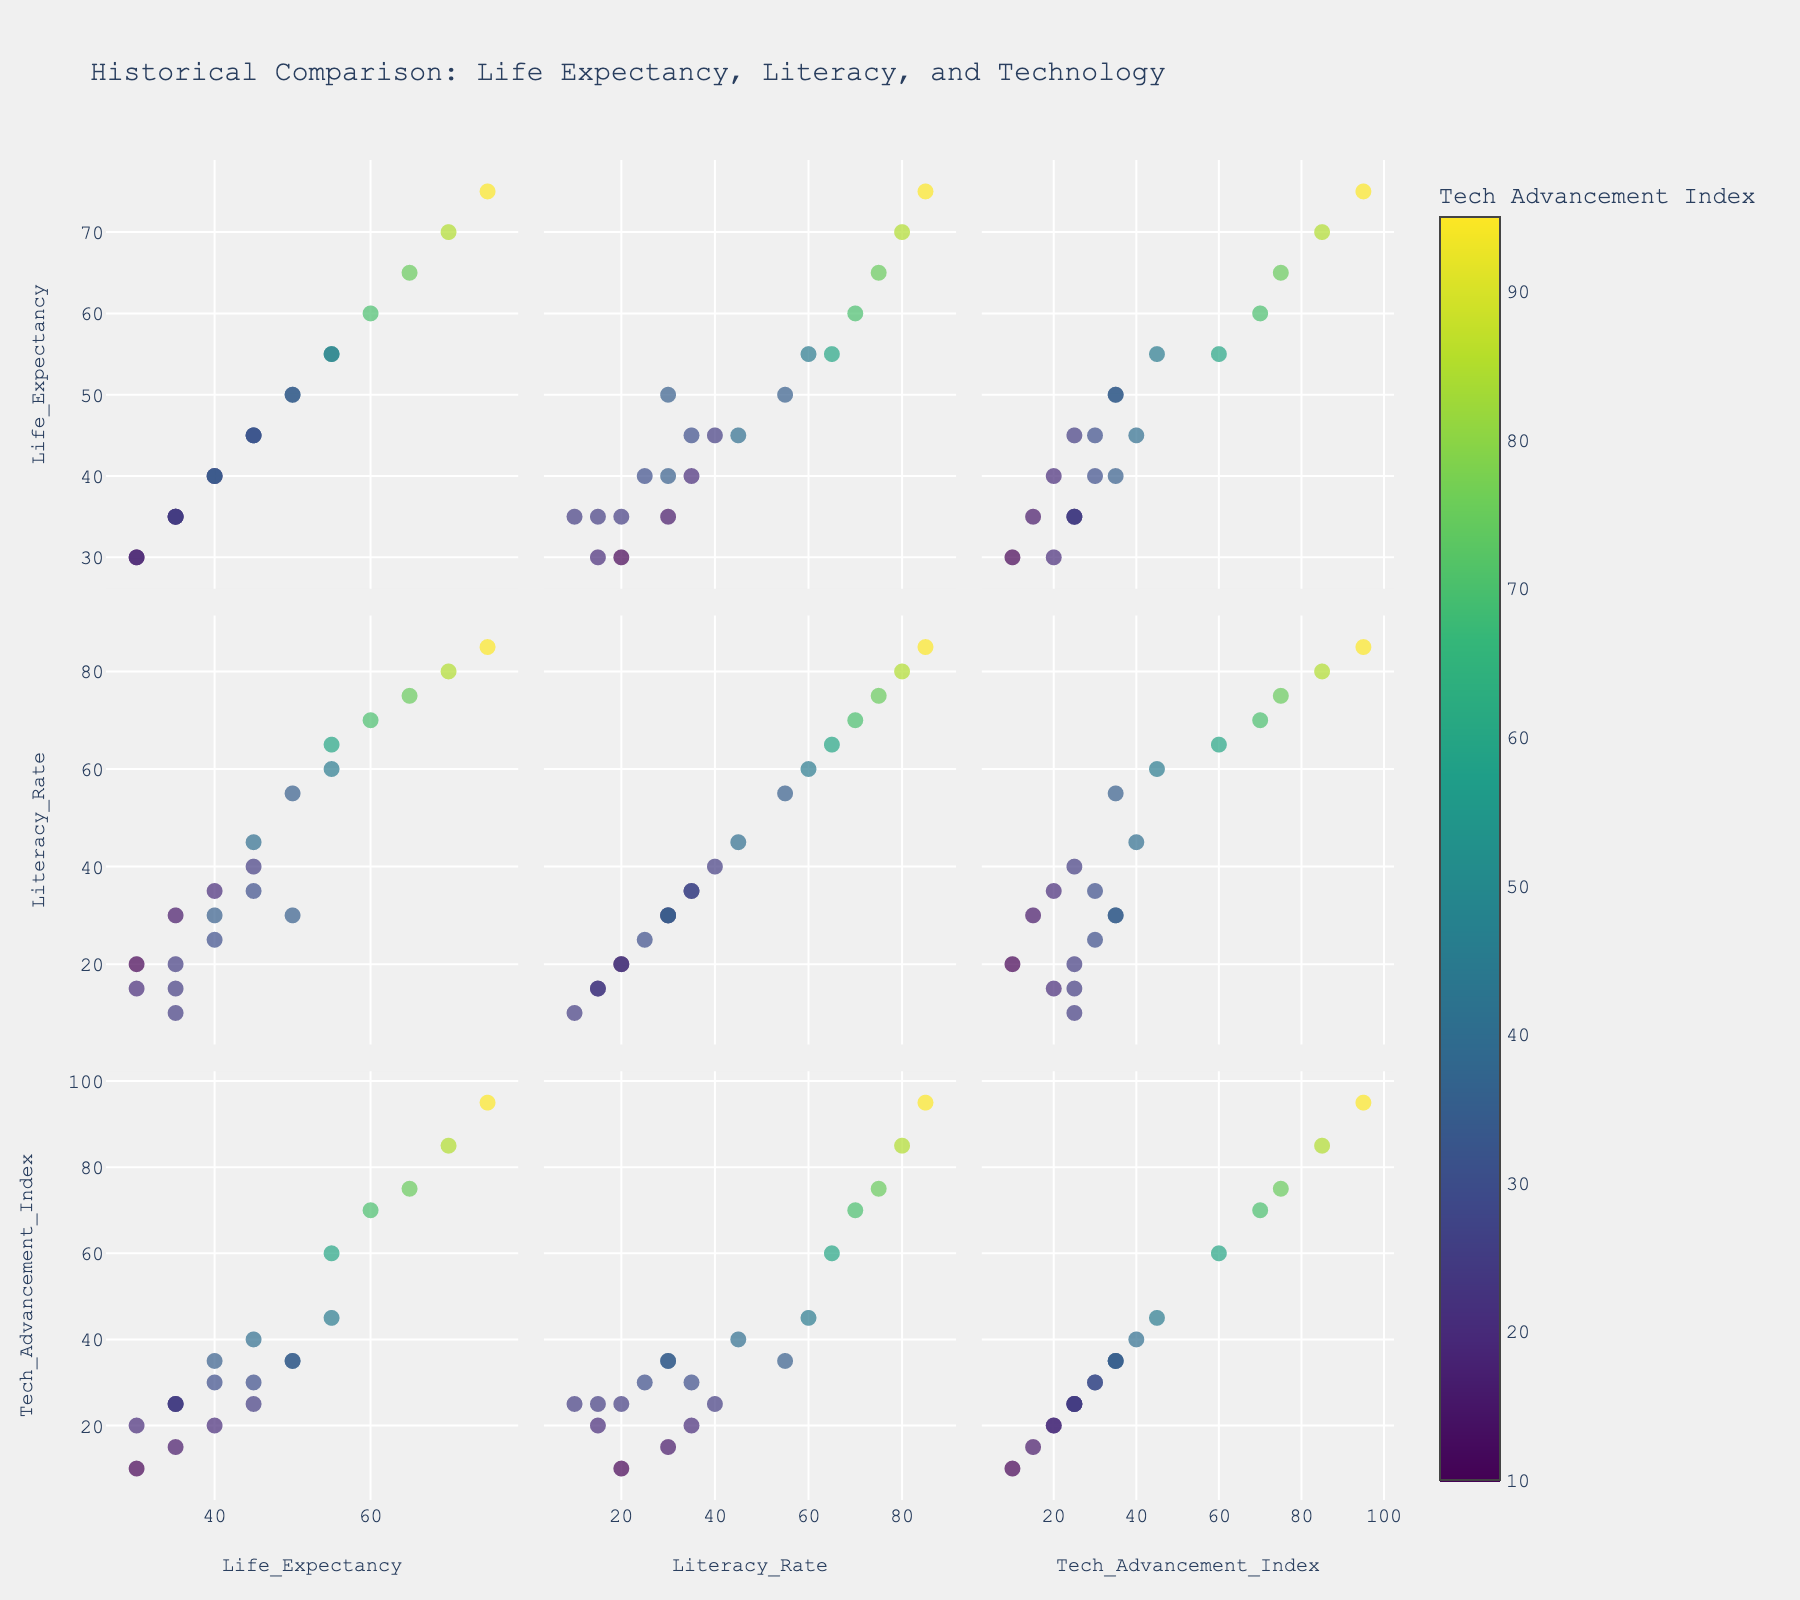What is the title of the figure? The title is typically placed at the top of the figure to give a comprehensive summary of what the plot represents. Look for the largest text that usually stands out.
Answer: Historical Comparison: Life Expectancy, Literacy, and Technology How many variables are compared in the scatter plot matrix? To determine the number of variables, count the distinct column titles/labels on the axes or the number of scatter plots along one side of the diagonal.
Answer: 3 Which historical period has the highest Tech Advancement Index? Identify the data point with the highest Tech Advancement Index by observing the color bar and finding the corresponding data point.
Answer: Information Age What is the general trend between Life Expectancy and Tech Advancement Index? Look at the scatter plots comparing Life Expectancy and Tech Advancement Index; assess whether increases in one variable correspond to increases in the other.
Answer: Positive correlation Which regions are included in the plot for the Roman Empire? Locate the data point corresponding to the Roman Empire and check the text/hover information to identify the region.
Answer: Europe In which historical periods is Life Expectancy above 50? Scan the scatter plots where Life Expectancy is on the y-axis and identify the periods above the 50 mark.
Answer: Enlightenment France, Industrial Revolution Britain, Victorian Era, Interwar Period, Post-WWII Era, Information Age Compare Literacy Rate during the Ancient Greece period and the Renaissance Italy period. Which one is higher? Locate the data points for Ancient Greece and Renaissance Italy and compare their positions on the y-axis for Literacy Rate.
Answer: Renaissance Italy How is the Life Expectancy in Enlightenment France different from that in the Industrial Revolution Britain? Find these two historical periods on the scatter plots involving Life Expectancy and compare their values.
Answer: Industrial Revolution Britain has higher Life Expectancy What color predominantly represents the highest tech advancement index in the figure? Refer to the color bar that shows the Tech Advancement Index and note the color representing the highest value.
Answer: Yellow Which period in East Asia has a higher Literacy Rate: Edo Period Japan or Qing Dynasty? Locate the data points for Edo Period Japan and Qing Dynasty in the scatter plots involving Literacy Rate and compare them.
Answer: Edo Period Japan 